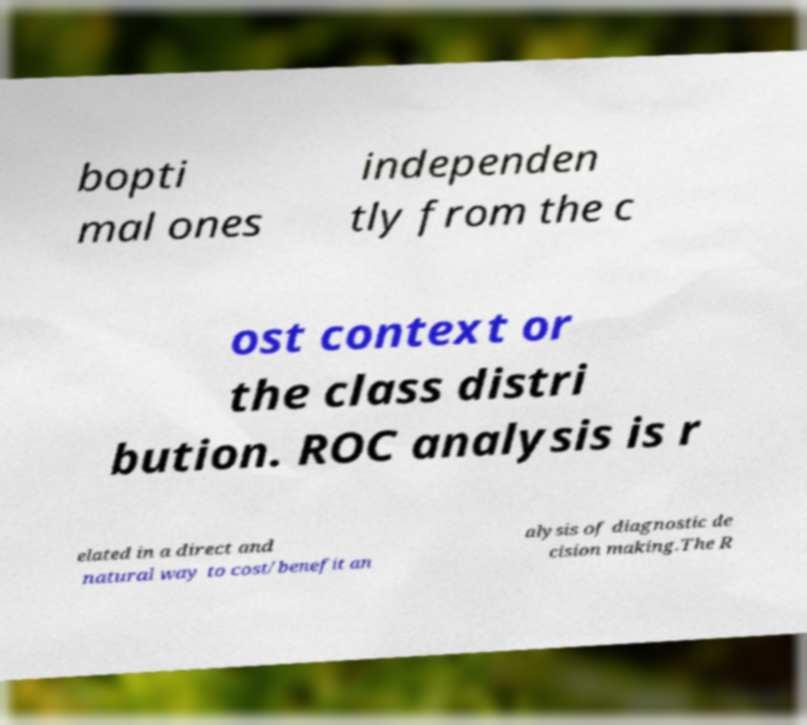Could you extract and type out the text from this image? bopti mal ones independen tly from the c ost context or the class distri bution. ROC analysis is r elated in a direct and natural way to cost/benefit an alysis of diagnostic de cision making.The R 